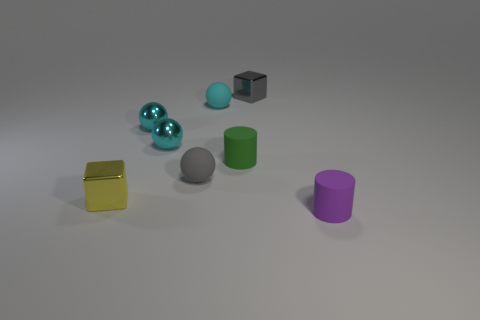Are there more rubber things behind the purple thing than small gray balls?
Provide a short and direct response. Yes. What number of cyan rubber balls are on the left side of the cube that is behind the ball that is to the right of the tiny gray sphere?
Your answer should be compact. 1. There is a rubber ball behind the small gray ball; is it the same size as the metal cube to the left of the tiny green object?
Keep it short and to the point. Yes. What is the small yellow object behind the small rubber object on the right side of the small gray metallic cube made of?
Keep it short and to the point. Metal. How many objects are either metallic blocks on the right side of the tiny yellow metal cube or big green spheres?
Ensure brevity in your answer.  1. Are there an equal number of matte things right of the small gray ball and rubber objects that are on the left side of the tiny gray block?
Keep it short and to the point. Yes. There is a small ball that is in front of the small cylinder behind the tiny metallic cube that is in front of the tiny green object; what is its material?
Your answer should be compact. Rubber. What size is the thing that is both in front of the gray ball and right of the yellow thing?
Keep it short and to the point. Small. Is the shape of the tiny gray rubber thing the same as the gray metallic object?
Make the answer very short. No. The tiny cyan thing that is made of the same material as the small green cylinder is what shape?
Your answer should be very brief. Sphere. 